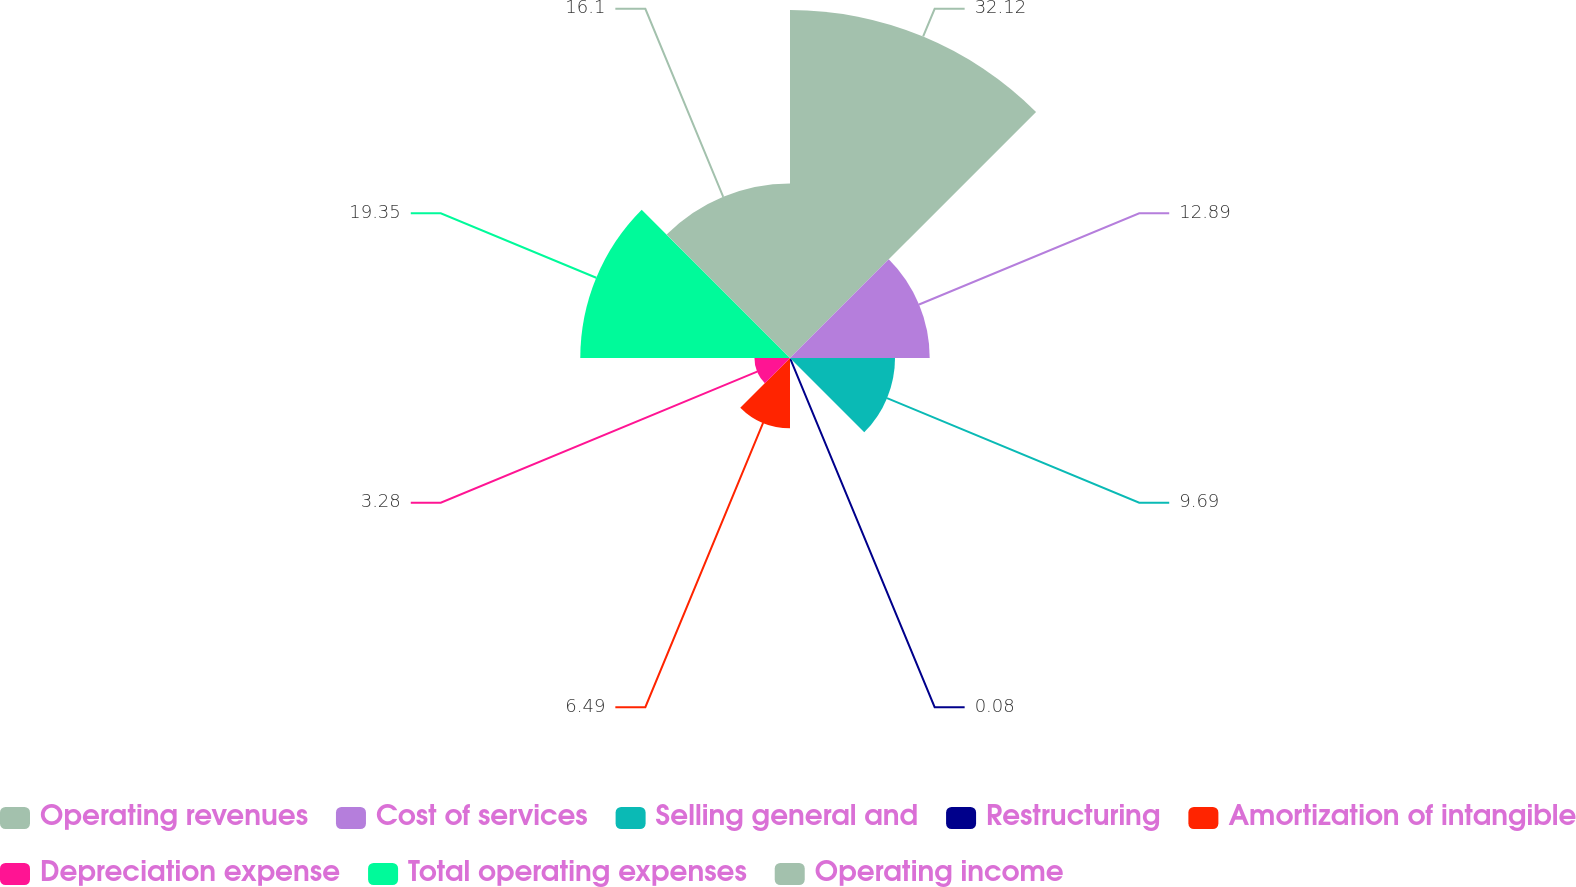Convert chart. <chart><loc_0><loc_0><loc_500><loc_500><pie_chart><fcel>Operating revenues<fcel>Cost of services<fcel>Selling general and<fcel>Restructuring<fcel>Amortization of intangible<fcel>Depreciation expense<fcel>Total operating expenses<fcel>Operating income<nl><fcel>32.11%<fcel>12.89%<fcel>9.69%<fcel>0.08%<fcel>6.49%<fcel>3.28%<fcel>19.35%<fcel>16.1%<nl></chart> 